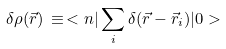<formula> <loc_0><loc_0><loc_500><loc_500>\delta \rho ( \vec { r } ) \, \equiv \, < n | \sum _ { i } \delta ( \vec { r } - \vec { r } _ { i } ) | 0 ></formula> 